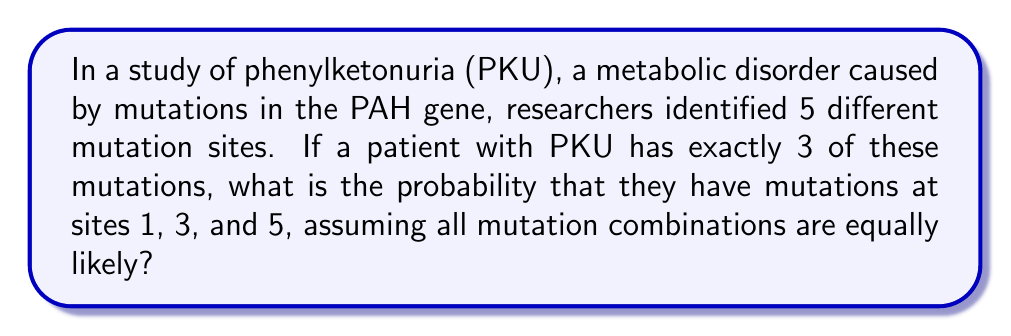Provide a solution to this math problem. Let's approach this step-by-step:

1) First, we need to determine the total number of ways to choose 3 mutations from 5 sites. This is a combination problem, denoted as $\binom{5}{3}$ or C(5,3).

2) The formula for this combination is:

   $$\binom{5}{3} = \frac{5!}{3!(5-3)!} = \frac{5!}{3!2!}$$

3) Let's calculate this:
   $$\frac{5 * 4 * 3!}{3! * 2 * 1} = \frac{20}{2} = 10$$

4) So there are 10 possible ways to have 3 mutations out of 5 sites.

5) The specific combination of mutations at sites 1, 3, and 5 is just one of these possibilities.

6) Since all mutation combinations are equally likely, the probability of any specific combination is 1 divided by the total number of possible combinations.

7) Therefore, the probability is $\frac{1}{10}$ or 0.1 or 10%.
Answer: $\frac{1}{10}$ 